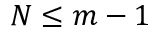<formula> <loc_0><loc_0><loc_500><loc_500>N \leq m - 1</formula> 